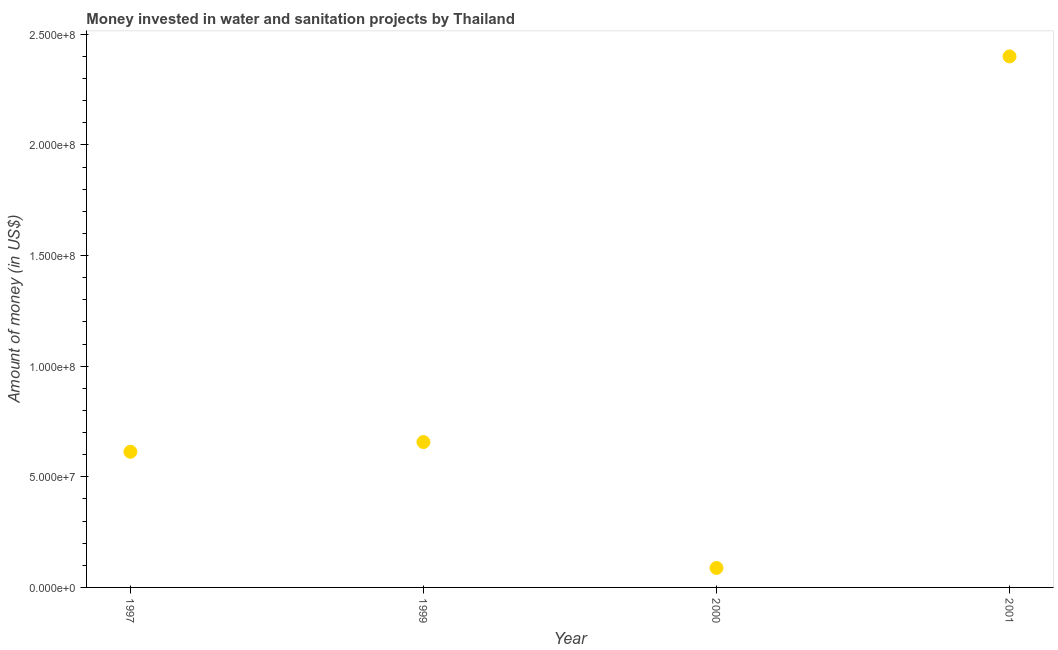What is the investment in 2000?
Give a very brief answer. 8.80e+06. Across all years, what is the maximum investment?
Your response must be concise. 2.40e+08. Across all years, what is the minimum investment?
Keep it short and to the point. 8.80e+06. In which year was the investment minimum?
Make the answer very short. 2000. What is the sum of the investment?
Provide a short and direct response. 3.76e+08. What is the difference between the investment in 1999 and 2000?
Keep it short and to the point. 5.69e+07. What is the average investment per year?
Keep it short and to the point. 9.40e+07. What is the median investment?
Give a very brief answer. 6.35e+07. In how many years, is the investment greater than 80000000 US$?
Provide a short and direct response. 1. What is the ratio of the investment in 1999 to that in 2000?
Give a very brief answer. 7.47. Is the difference between the investment in 1999 and 2000 greater than the difference between any two years?
Offer a terse response. No. What is the difference between the highest and the second highest investment?
Provide a succinct answer. 1.74e+08. What is the difference between the highest and the lowest investment?
Keep it short and to the point. 2.31e+08. Does the investment monotonically increase over the years?
Your answer should be compact. No. What is the difference between two consecutive major ticks on the Y-axis?
Ensure brevity in your answer.  5.00e+07. What is the title of the graph?
Provide a succinct answer. Money invested in water and sanitation projects by Thailand. What is the label or title of the Y-axis?
Offer a terse response. Amount of money (in US$). What is the Amount of money (in US$) in 1997?
Provide a succinct answer. 6.13e+07. What is the Amount of money (in US$) in 1999?
Offer a very short reply. 6.57e+07. What is the Amount of money (in US$) in 2000?
Offer a terse response. 8.80e+06. What is the Amount of money (in US$) in 2001?
Ensure brevity in your answer.  2.40e+08. What is the difference between the Amount of money (in US$) in 1997 and 1999?
Make the answer very short. -4.40e+06. What is the difference between the Amount of money (in US$) in 1997 and 2000?
Offer a terse response. 5.25e+07. What is the difference between the Amount of money (in US$) in 1997 and 2001?
Your response must be concise. -1.79e+08. What is the difference between the Amount of money (in US$) in 1999 and 2000?
Make the answer very short. 5.69e+07. What is the difference between the Amount of money (in US$) in 1999 and 2001?
Make the answer very short. -1.74e+08. What is the difference between the Amount of money (in US$) in 2000 and 2001?
Ensure brevity in your answer.  -2.31e+08. What is the ratio of the Amount of money (in US$) in 1997 to that in 1999?
Make the answer very short. 0.93. What is the ratio of the Amount of money (in US$) in 1997 to that in 2000?
Give a very brief answer. 6.97. What is the ratio of the Amount of money (in US$) in 1997 to that in 2001?
Your answer should be compact. 0.26. What is the ratio of the Amount of money (in US$) in 1999 to that in 2000?
Give a very brief answer. 7.47. What is the ratio of the Amount of money (in US$) in 1999 to that in 2001?
Your answer should be very brief. 0.27. What is the ratio of the Amount of money (in US$) in 2000 to that in 2001?
Ensure brevity in your answer.  0.04. 